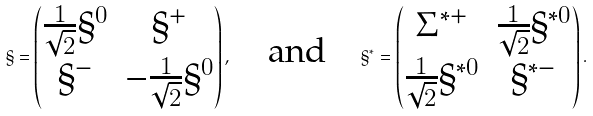<formula> <loc_0><loc_0><loc_500><loc_500>\S = \begin{pmatrix} \frac { 1 } { \sqrt { 2 } } \S ^ { 0 } & \S ^ { + } \\ \S ^ { - } & - \frac { 1 } { \sqrt { 2 } } \S ^ { 0 } \end{pmatrix} , \quad \text {and} \quad \S ^ { * } = \begin{pmatrix} \Sigma ^ { * + } & \frac { 1 } { \sqrt { 2 } } \S ^ { * 0 } \\ \frac { 1 } { \sqrt { 2 } } \S ^ { * 0 } & \S ^ { * - } \end{pmatrix} .</formula> 